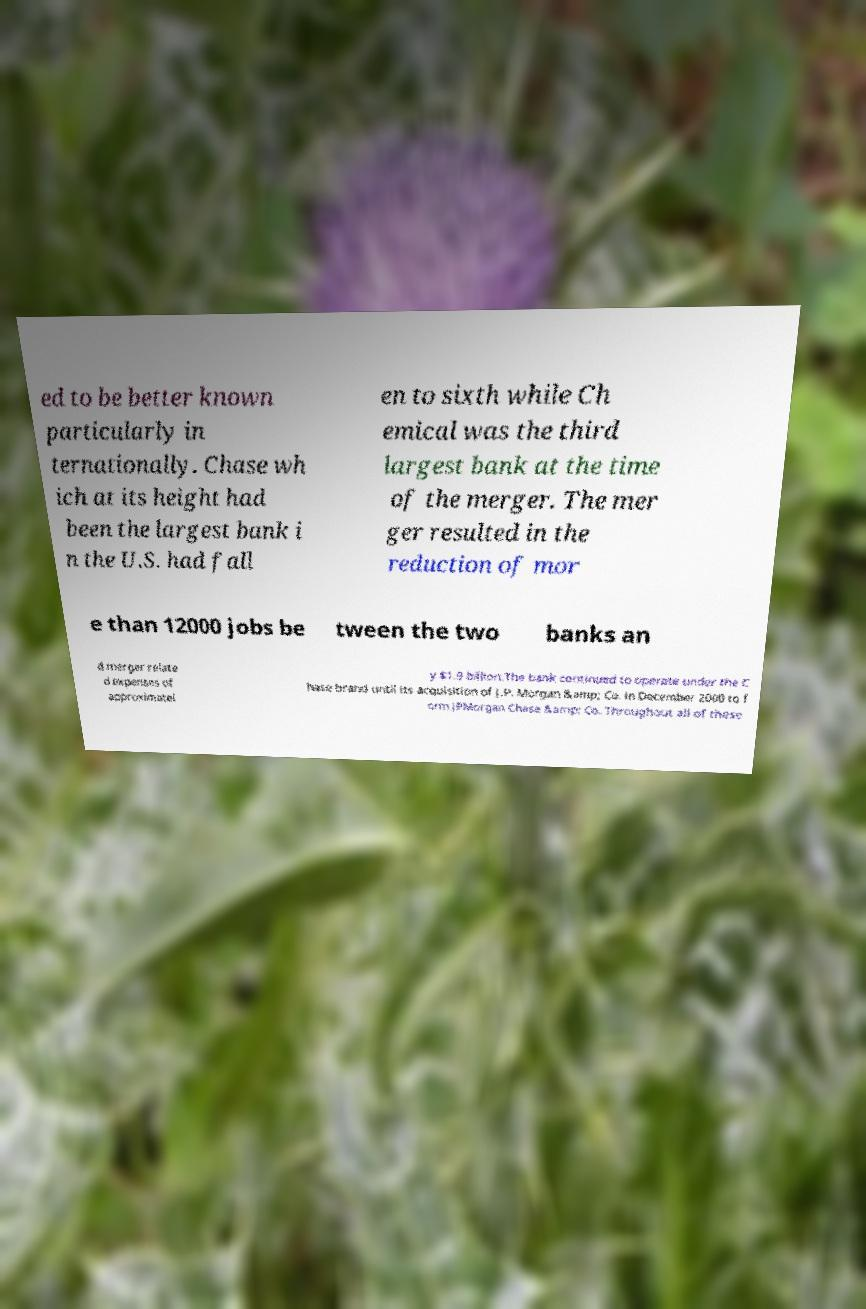Please read and relay the text visible in this image. What does it say? ed to be better known particularly in ternationally. Chase wh ich at its height had been the largest bank i n the U.S. had fall en to sixth while Ch emical was the third largest bank at the time of the merger. The mer ger resulted in the reduction of mor e than 12000 jobs be tween the two banks an d merger relate d expenses of approximatel y $1.9 billion.The bank continued to operate under the C hase brand until its acquisition of J.P. Morgan &amp; Co. in December 2000 to f orm JPMorgan Chase &amp; Co. Throughout all of these 